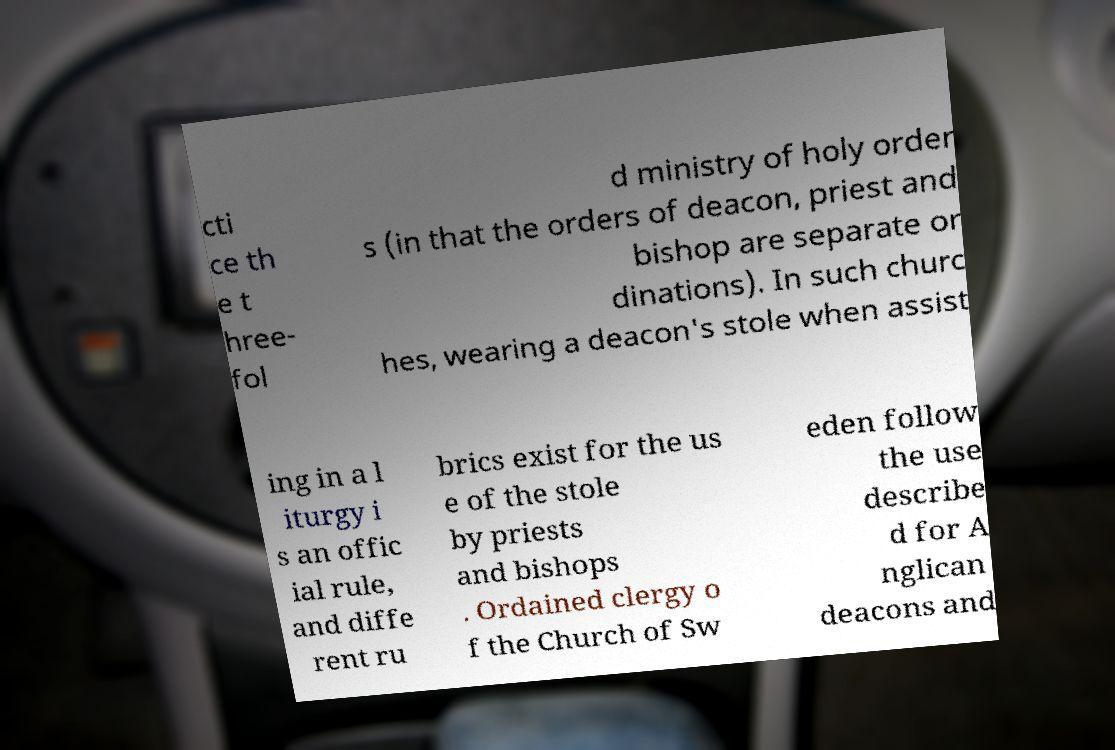What messages or text are displayed in this image? I need them in a readable, typed format. cti ce th e t hree- fol d ministry of holy order s (in that the orders of deacon, priest and bishop are separate or dinations). In such churc hes, wearing a deacon's stole when assist ing in a l iturgy i s an offic ial rule, and diffe rent ru brics exist for the us e of the stole by priests and bishops . Ordained clergy o f the Church of Sw eden follow the use describe d for A nglican deacons and 